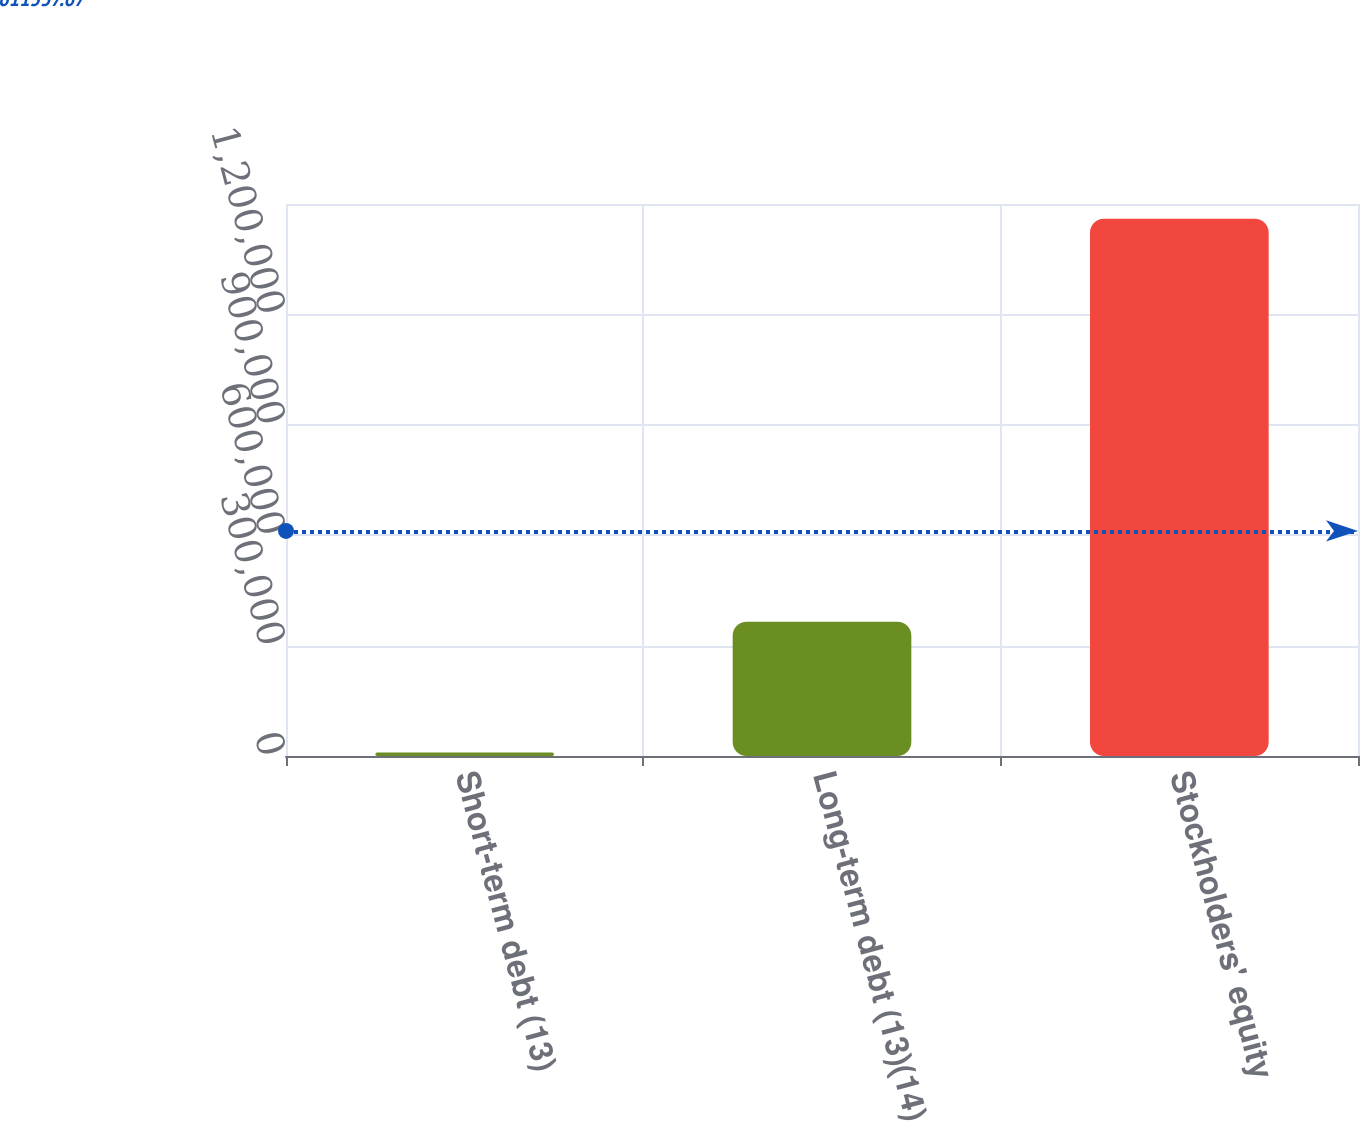Convert chart to OTSL. <chart><loc_0><loc_0><loc_500><loc_500><bar_chart><fcel>Short-term debt (13)<fcel>Long-term debt (13)(14)<fcel>Stockholders' equity<nl><fcel>9714<fcel>364874<fcel>1.46008e+06<nl></chart> 